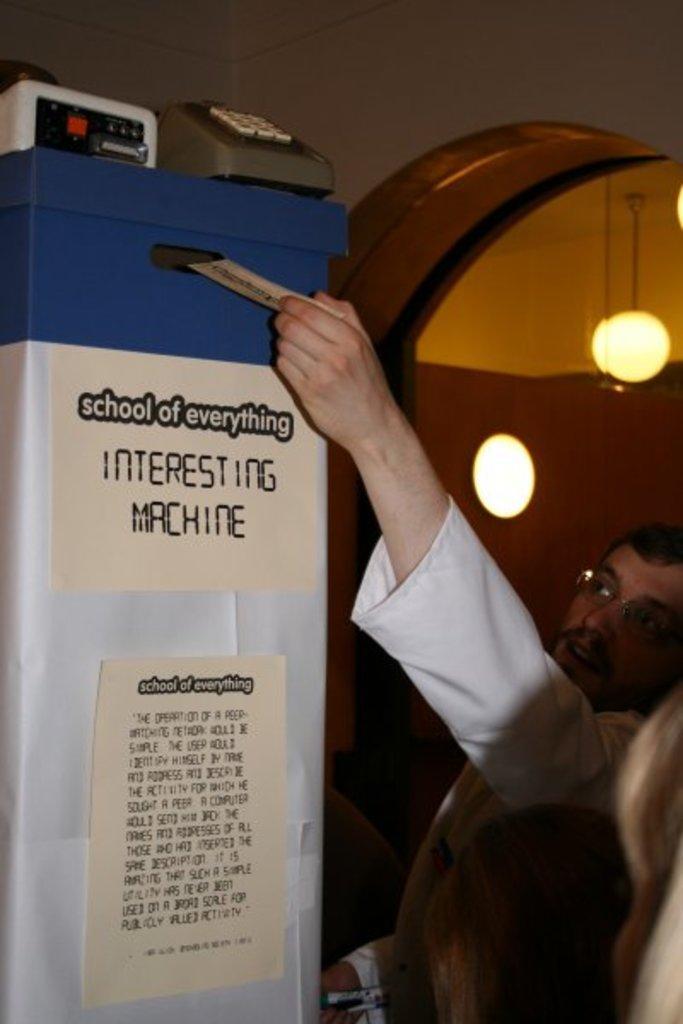Could you give a brief overview of what you see in this image? On the left side, we see an object or a machine in white and blue color. We see the posters in white color are pasted on the machine. We see some text written on the posters. On top of the machine, we see a telephone and a white color object. In the right bottom, we see the heads of two women. Beside them, we see a man is standing. In the background, we see a wall and the lanterns. 